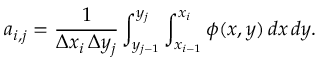<formula> <loc_0><loc_0><loc_500><loc_500>a _ { i , j } = \frac { 1 } { \Delta x _ { i } \, \Delta y _ { j } } \int _ { y _ { j - 1 } } ^ { y _ { j } } \int _ { x _ { i - 1 } } ^ { x _ { i } } \phi ( x , y ) \, d x \, d y .</formula> 